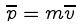Convert formula to latex. <formula><loc_0><loc_0><loc_500><loc_500>\overline { p } = m \overline { v }</formula> 